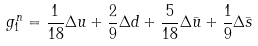<formula> <loc_0><loc_0><loc_500><loc_500>g _ { 1 } ^ { n } = \frac { 1 } { 1 8 } \Delta u + \frac { 2 } { 9 } \Delta d + \frac { 5 } { 1 8 } \Delta \bar { u } + \frac { 1 } { 9 } \Delta \bar { s }</formula> 